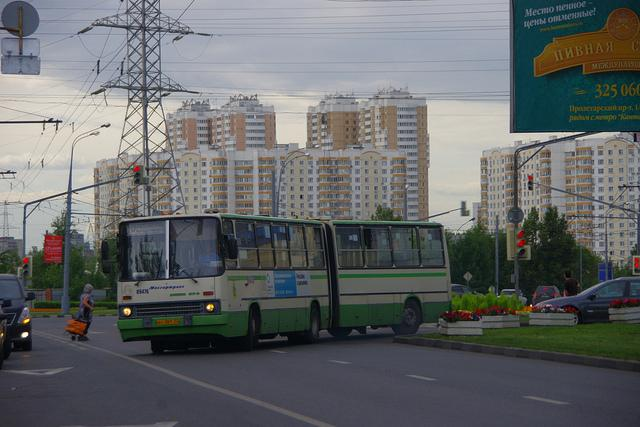What is the woman trying to do? Please explain your reasoning. cross street. The woman wants to cross. 